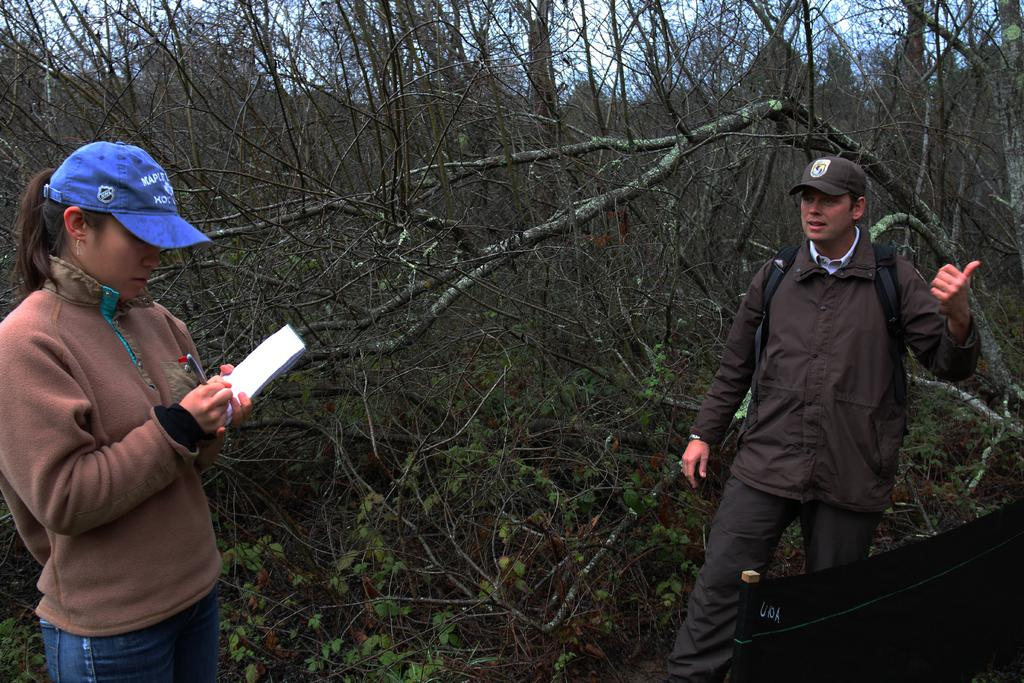What is the lady on the left side of the image holding? The lady is holding a book and a pen. What might the lady be doing with the book and pen? The lady might be reading or writing with the book and pen. Who is on the right side of the image? There is a man on the right side of the image. What can be seen in the background of the image? There are trees and the sky visible in the background of the image. How does the lady measure the distance between the trees in the image? There is no indication in the image that the lady is measuring anything, and no measuring tools are visible. 